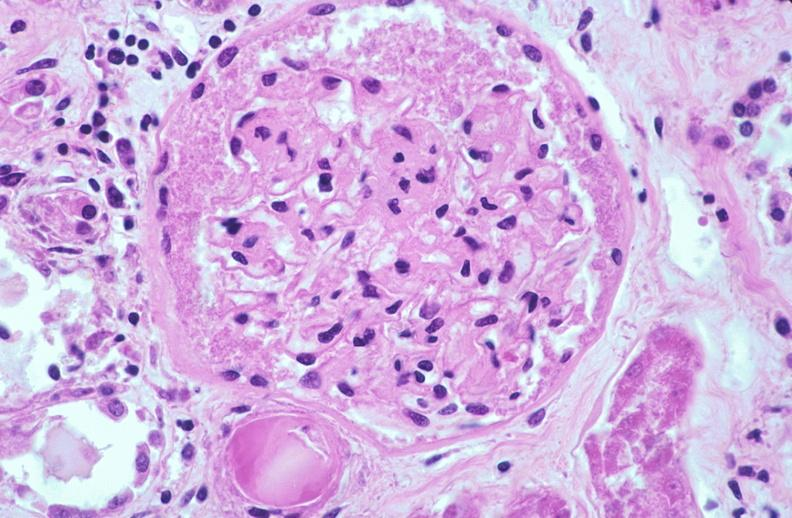does this image show kidney glomerulus, thickened and hyalinized basement membranes fibrin caps due to diabetes mellitus?
Answer the question using a single word or phrase. Yes 